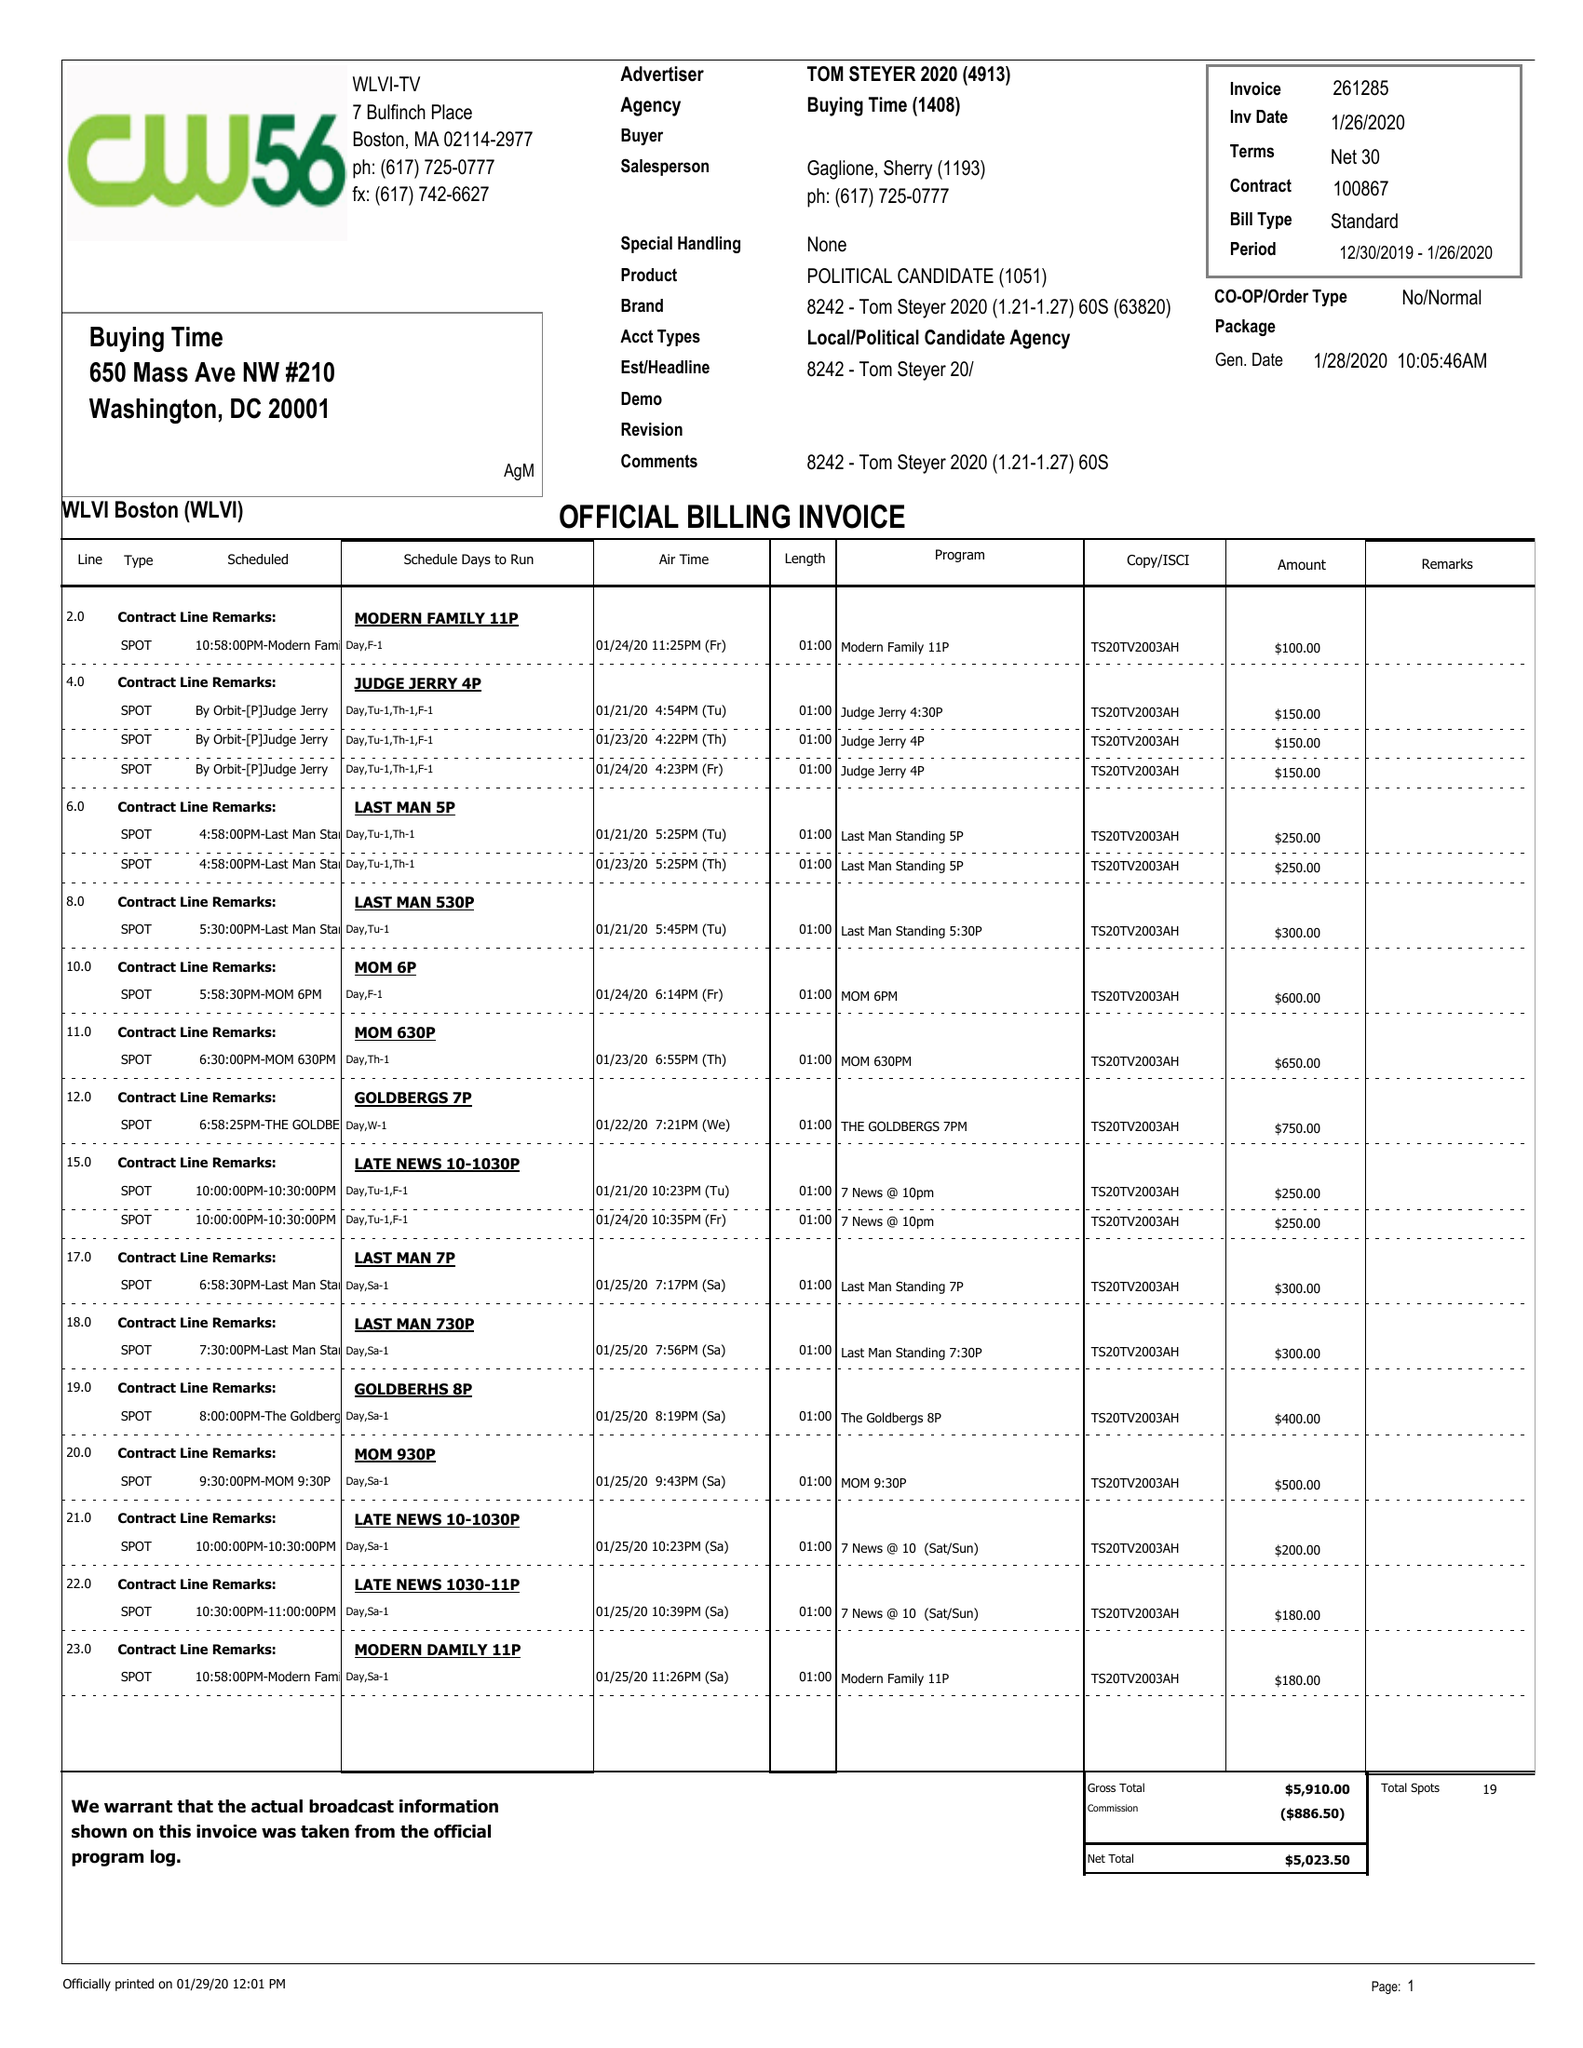What is the value for the advertiser?
Answer the question using a single word or phrase. TOM STEYER 2020 